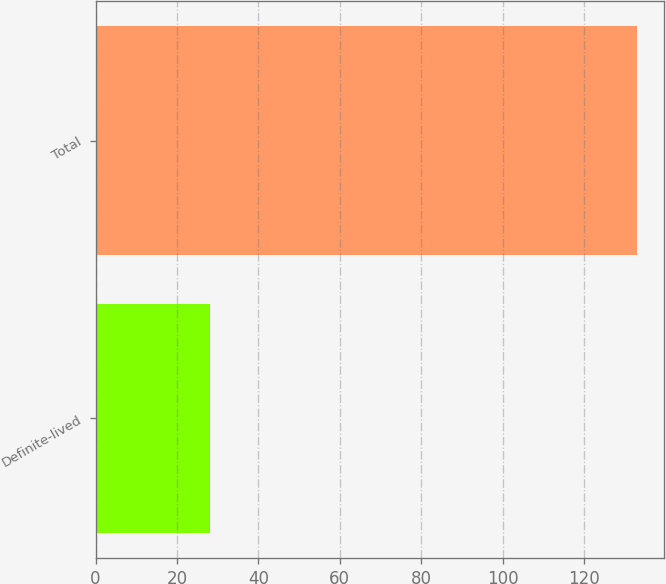Convert chart to OTSL. <chart><loc_0><loc_0><loc_500><loc_500><bar_chart><fcel>Definite-lived<fcel>Total<nl><fcel>28<fcel>133<nl></chart> 